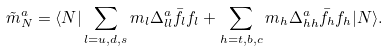<formula> <loc_0><loc_0><loc_500><loc_500>\tilde { m } _ { N } ^ { a } = \langle N | \sum _ { l = u , d , s } m _ { l } \Delta _ { l l } ^ { a } \bar { f _ { l } } f _ { l } + \sum _ { h = t , b , c } m _ { h } \Delta _ { h h } ^ { a } \bar { f _ { h } } f _ { h } | N \rangle .</formula> 